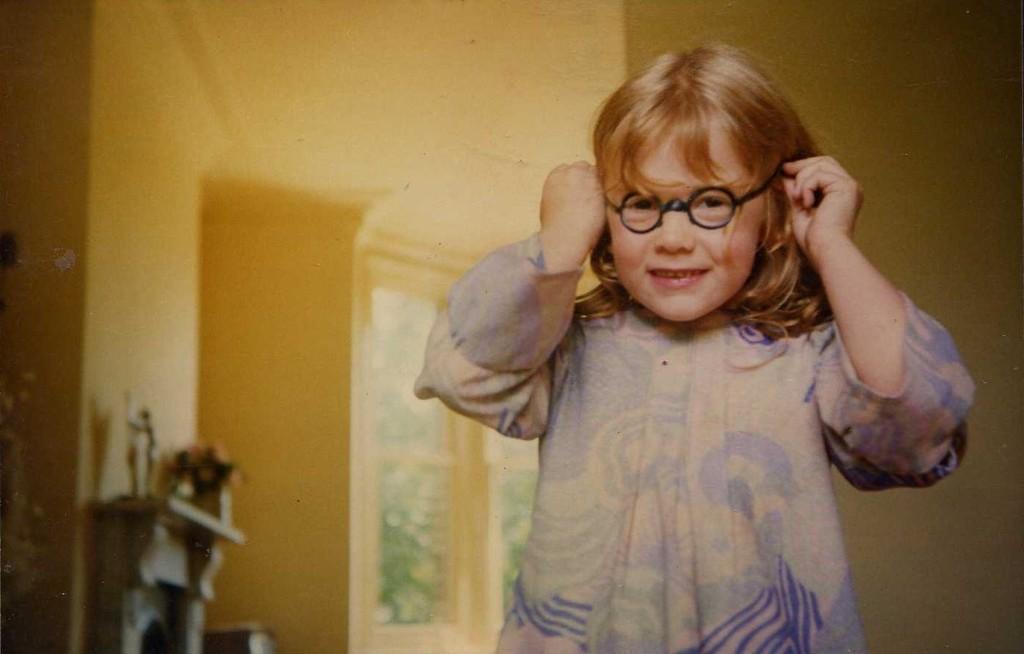Describe this image in one or two sentences. In this picture, we can see a person holding spectacles, and in the background we can see the wall and some objects. 